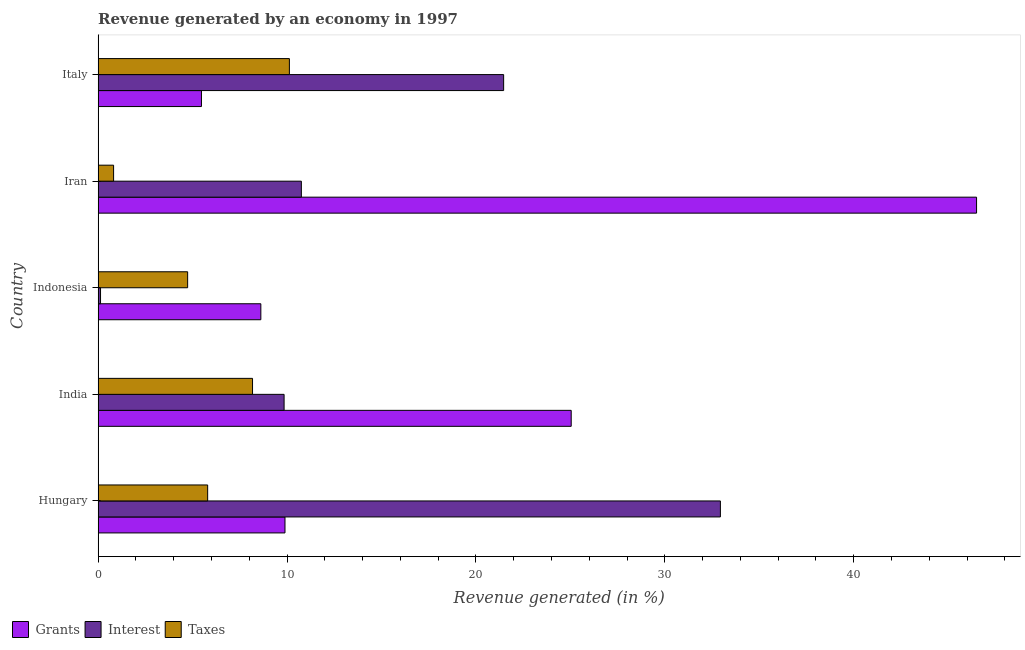How many groups of bars are there?
Your answer should be compact. 5. Are the number of bars per tick equal to the number of legend labels?
Make the answer very short. Yes. What is the percentage of revenue generated by interest in Hungary?
Offer a terse response. 32.94. Across all countries, what is the maximum percentage of revenue generated by interest?
Provide a succinct answer. 32.94. Across all countries, what is the minimum percentage of revenue generated by taxes?
Give a very brief answer. 0.82. In which country was the percentage of revenue generated by taxes minimum?
Make the answer very short. Iran. What is the total percentage of revenue generated by interest in the graph?
Your answer should be very brief. 75.14. What is the difference between the percentage of revenue generated by taxes in India and that in Iran?
Make the answer very short. 7.36. What is the difference between the percentage of revenue generated by interest in Iran and the percentage of revenue generated by grants in India?
Make the answer very short. -14.29. What is the average percentage of revenue generated by grants per country?
Your answer should be compact. 19.11. What is the difference between the percentage of revenue generated by taxes and percentage of revenue generated by interest in Indonesia?
Your answer should be very brief. 4.61. In how many countries, is the percentage of revenue generated by grants greater than 20 %?
Your answer should be compact. 2. What is the ratio of the percentage of revenue generated by interest in Indonesia to that in Iran?
Provide a short and direct response. 0.01. Is the percentage of revenue generated by grants in India less than that in Iran?
Provide a short and direct response. Yes. Is the difference between the percentage of revenue generated by grants in India and Iran greater than the difference between the percentage of revenue generated by interest in India and Iran?
Provide a short and direct response. No. What is the difference between the highest and the second highest percentage of revenue generated by taxes?
Ensure brevity in your answer.  1.95. What is the difference between the highest and the lowest percentage of revenue generated by taxes?
Provide a succinct answer. 9.31. In how many countries, is the percentage of revenue generated by interest greater than the average percentage of revenue generated by interest taken over all countries?
Your answer should be very brief. 2. Is the sum of the percentage of revenue generated by taxes in Hungary and Indonesia greater than the maximum percentage of revenue generated by grants across all countries?
Keep it short and to the point. No. What does the 2nd bar from the top in Italy represents?
Your answer should be very brief. Interest. What does the 1st bar from the bottom in India represents?
Provide a short and direct response. Grants. Is it the case that in every country, the sum of the percentage of revenue generated by grants and percentage of revenue generated by interest is greater than the percentage of revenue generated by taxes?
Provide a short and direct response. Yes. How many bars are there?
Give a very brief answer. 15. Are all the bars in the graph horizontal?
Your response must be concise. Yes. How many countries are there in the graph?
Give a very brief answer. 5. What is the difference between two consecutive major ticks on the X-axis?
Your answer should be very brief. 10. Does the graph contain any zero values?
Provide a short and direct response. No. How are the legend labels stacked?
Keep it short and to the point. Horizontal. What is the title of the graph?
Provide a short and direct response. Revenue generated by an economy in 1997. What is the label or title of the X-axis?
Provide a succinct answer. Revenue generated (in %). What is the label or title of the Y-axis?
Your answer should be compact. Country. What is the Revenue generated (in %) in Grants in Hungary?
Keep it short and to the point. 9.89. What is the Revenue generated (in %) of Interest in Hungary?
Offer a terse response. 32.94. What is the Revenue generated (in %) of Taxes in Hungary?
Make the answer very short. 5.8. What is the Revenue generated (in %) of Grants in India?
Provide a succinct answer. 25.04. What is the Revenue generated (in %) of Interest in India?
Your response must be concise. 9.85. What is the Revenue generated (in %) in Taxes in India?
Provide a succinct answer. 8.17. What is the Revenue generated (in %) of Grants in Indonesia?
Ensure brevity in your answer.  8.61. What is the Revenue generated (in %) of Interest in Indonesia?
Provide a short and direct response. 0.13. What is the Revenue generated (in %) of Taxes in Indonesia?
Your response must be concise. 4.74. What is the Revenue generated (in %) of Grants in Iran?
Provide a short and direct response. 46.5. What is the Revenue generated (in %) of Interest in Iran?
Give a very brief answer. 10.76. What is the Revenue generated (in %) of Taxes in Iran?
Keep it short and to the point. 0.82. What is the Revenue generated (in %) in Grants in Italy?
Your answer should be very brief. 5.47. What is the Revenue generated (in %) in Interest in Italy?
Give a very brief answer. 21.47. What is the Revenue generated (in %) of Taxes in Italy?
Provide a succinct answer. 10.13. Across all countries, what is the maximum Revenue generated (in %) in Grants?
Your answer should be very brief. 46.5. Across all countries, what is the maximum Revenue generated (in %) of Interest?
Offer a very short reply. 32.94. Across all countries, what is the maximum Revenue generated (in %) of Taxes?
Your answer should be very brief. 10.13. Across all countries, what is the minimum Revenue generated (in %) in Grants?
Your answer should be compact. 5.47. Across all countries, what is the minimum Revenue generated (in %) of Interest?
Give a very brief answer. 0.13. Across all countries, what is the minimum Revenue generated (in %) of Taxes?
Offer a terse response. 0.82. What is the total Revenue generated (in %) in Grants in the graph?
Offer a very short reply. 95.52. What is the total Revenue generated (in %) in Interest in the graph?
Offer a terse response. 75.14. What is the total Revenue generated (in %) of Taxes in the graph?
Provide a succinct answer. 29.66. What is the difference between the Revenue generated (in %) of Grants in Hungary and that in India?
Your answer should be compact. -15.15. What is the difference between the Revenue generated (in %) in Interest in Hungary and that in India?
Keep it short and to the point. 23.1. What is the difference between the Revenue generated (in %) in Taxes in Hungary and that in India?
Your answer should be very brief. -2.37. What is the difference between the Revenue generated (in %) in Grants in Hungary and that in Indonesia?
Provide a succinct answer. 1.28. What is the difference between the Revenue generated (in %) of Interest in Hungary and that in Indonesia?
Provide a succinct answer. 32.81. What is the difference between the Revenue generated (in %) in Taxes in Hungary and that in Indonesia?
Your response must be concise. 1.06. What is the difference between the Revenue generated (in %) of Grants in Hungary and that in Iran?
Provide a succinct answer. -36.61. What is the difference between the Revenue generated (in %) in Interest in Hungary and that in Iran?
Provide a short and direct response. 22.18. What is the difference between the Revenue generated (in %) in Taxes in Hungary and that in Iran?
Your answer should be compact. 4.98. What is the difference between the Revenue generated (in %) in Grants in Hungary and that in Italy?
Your answer should be compact. 4.42. What is the difference between the Revenue generated (in %) of Interest in Hungary and that in Italy?
Make the answer very short. 11.47. What is the difference between the Revenue generated (in %) of Taxes in Hungary and that in Italy?
Your response must be concise. -4.33. What is the difference between the Revenue generated (in %) in Grants in India and that in Indonesia?
Offer a terse response. 16.43. What is the difference between the Revenue generated (in %) in Interest in India and that in Indonesia?
Provide a succinct answer. 9.72. What is the difference between the Revenue generated (in %) in Taxes in India and that in Indonesia?
Give a very brief answer. 3.44. What is the difference between the Revenue generated (in %) in Grants in India and that in Iran?
Your response must be concise. -21.46. What is the difference between the Revenue generated (in %) in Interest in India and that in Iran?
Offer a very short reply. -0.91. What is the difference between the Revenue generated (in %) of Taxes in India and that in Iran?
Make the answer very short. 7.36. What is the difference between the Revenue generated (in %) in Grants in India and that in Italy?
Make the answer very short. 19.57. What is the difference between the Revenue generated (in %) in Interest in India and that in Italy?
Make the answer very short. -11.62. What is the difference between the Revenue generated (in %) of Taxes in India and that in Italy?
Your answer should be compact. -1.95. What is the difference between the Revenue generated (in %) in Grants in Indonesia and that in Iran?
Ensure brevity in your answer.  -37.89. What is the difference between the Revenue generated (in %) of Interest in Indonesia and that in Iran?
Keep it short and to the point. -10.63. What is the difference between the Revenue generated (in %) of Taxes in Indonesia and that in Iran?
Your response must be concise. 3.92. What is the difference between the Revenue generated (in %) of Grants in Indonesia and that in Italy?
Your answer should be compact. 3.14. What is the difference between the Revenue generated (in %) in Interest in Indonesia and that in Italy?
Your answer should be very brief. -21.34. What is the difference between the Revenue generated (in %) of Taxes in Indonesia and that in Italy?
Your answer should be very brief. -5.39. What is the difference between the Revenue generated (in %) of Grants in Iran and that in Italy?
Ensure brevity in your answer.  41.03. What is the difference between the Revenue generated (in %) in Interest in Iran and that in Italy?
Provide a short and direct response. -10.71. What is the difference between the Revenue generated (in %) in Taxes in Iran and that in Italy?
Give a very brief answer. -9.31. What is the difference between the Revenue generated (in %) in Grants in Hungary and the Revenue generated (in %) in Interest in India?
Provide a short and direct response. 0.05. What is the difference between the Revenue generated (in %) in Grants in Hungary and the Revenue generated (in %) in Taxes in India?
Give a very brief answer. 1.72. What is the difference between the Revenue generated (in %) in Interest in Hungary and the Revenue generated (in %) in Taxes in India?
Provide a succinct answer. 24.77. What is the difference between the Revenue generated (in %) in Grants in Hungary and the Revenue generated (in %) in Interest in Indonesia?
Give a very brief answer. 9.76. What is the difference between the Revenue generated (in %) of Grants in Hungary and the Revenue generated (in %) of Taxes in Indonesia?
Ensure brevity in your answer.  5.15. What is the difference between the Revenue generated (in %) of Interest in Hungary and the Revenue generated (in %) of Taxes in Indonesia?
Give a very brief answer. 28.2. What is the difference between the Revenue generated (in %) of Grants in Hungary and the Revenue generated (in %) of Interest in Iran?
Make the answer very short. -0.87. What is the difference between the Revenue generated (in %) of Grants in Hungary and the Revenue generated (in %) of Taxes in Iran?
Offer a very short reply. 9.07. What is the difference between the Revenue generated (in %) in Interest in Hungary and the Revenue generated (in %) in Taxes in Iran?
Give a very brief answer. 32.12. What is the difference between the Revenue generated (in %) in Grants in Hungary and the Revenue generated (in %) in Interest in Italy?
Provide a succinct answer. -11.58. What is the difference between the Revenue generated (in %) of Grants in Hungary and the Revenue generated (in %) of Taxes in Italy?
Your response must be concise. -0.23. What is the difference between the Revenue generated (in %) in Interest in Hungary and the Revenue generated (in %) in Taxes in Italy?
Ensure brevity in your answer.  22.82. What is the difference between the Revenue generated (in %) of Grants in India and the Revenue generated (in %) of Interest in Indonesia?
Offer a terse response. 24.92. What is the difference between the Revenue generated (in %) of Grants in India and the Revenue generated (in %) of Taxes in Indonesia?
Provide a short and direct response. 20.31. What is the difference between the Revenue generated (in %) in Interest in India and the Revenue generated (in %) in Taxes in Indonesia?
Offer a very short reply. 5.11. What is the difference between the Revenue generated (in %) in Grants in India and the Revenue generated (in %) in Interest in Iran?
Ensure brevity in your answer.  14.29. What is the difference between the Revenue generated (in %) of Grants in India and the Revenue generated (in %) of Taxes in Iran?
Your answer should be very brief. 24.23. What is the difference between the Revenue generated (in %) in Interest in India and the Revenue generated (in %) in Taxes in Iran?
Keep it short and to the point. 9.03. What is the difference between the Revenue generated (in %) in Grants in India and the Revenue generated (in %) in Interest in Italy?
Ensure brevity in your answer.  3.58. What is the difference between the Revenue generated (in %) in Grants in India and the Revenue generated (in %) in Taxes in Italy?
Your response must be concise. 14.92. What is the difference between the Revenue generated (in %) of Interest in India and the Revenue generated (in %) of Taxes in Italy?
Make the answer very short. -0.28. What is the difference between the Revenue generated (in %) of Grants in Indonesia and the Revenue generated (in %) of Interest in Iran?
Keep it short and to the point. -2.15. What is the difference between the Revenue generated (in %) in Grants in Indonesia and the Revenue generated (in %) in Taxes in Iran?
Ensure brevity in your answer.  7.8. What is the difference between the Revenue generated (in %) in Interest in Indonesia and the Revenue generated (in %) in Taxes in Iran?
Make the answer very short. -0.69. What is the difference between the Revenue generated (in %) of Grants in Indonesia and the Revenue generated (in %) of Interest in Italy?
Your response must be concise. -12.85. What is the difference between the Revenue generated (in %) of Grants in Indonesia and the Revenue generated (in %) of Taxes in Italy?
Give a very brief answer. -1.51. What is the difference between the Revenue generated (in %) in Interest in Indonesia and the Revenue generated (in %) in Taxes in Italy?
Offer a terse response. -10. What is the difference between the Revenue generated (in %) in Grants in Iran and the Revenue generated (in %) in Interest in Italy?
Keep it short and to the point. 25.04. What is the difference between the Revenue generated (in %) of Grants in Iran and the Revenue generated (in %) of Taxes in Italy?
Ensure brevity in your answer.  36.38. What is the difference between the Revenue generated (in %) of Interest in Iran and the Revenue generated (in %) of Taxes in Italy?
Make the answer very short. 0.63. What is the average Revenue generated (in %) in Grants per country?
Your answer should be compact. 19.1. What is the average Revenue generated (in %) of Interest per country?
Ensure brevity in your answer.  15.03. What is the average Revenue generated (in %) of Taxes per country?
Keep it short and to the point. 5.93. What is the difference between the Revenue generated (in %) of Grants and Revenue generated (in %) of Interest in Hungary?
Your answer should be very brief. -23.05. What is the difference between the Revenue generated (in %) of Grants and Revenue generated (in %) of Taxes in Hungary?
Keep it short and to the point. 4.09. What is the difference between the Revenue generated (in %) in Interest and Revenue generated (in %) in Taxes in Hungary?
Your response must be concise. 27.14. What is the difference between the Revenue generated (in %) in Grants and Revenue generated (in %) in Interest in India?
Provide a succinct answer. 15.2. What is the difference between the Revenue generated (in %) of Grants and Revenue generated (in %) of Taxes in India?
Your answer should be compact. 16.87. What is the difference between the Revenue generated (in %) of Interest and Revenue generated (in %) of Taxes in India?
Make the answer very short. 1.67. What is the difference between the Revenue generated (in %) in Grants and Revenue generated (in %) in Interest in Indonesia?
Make the answer very short. 8.49. What is the difference between the Revenue generated (in %) of Grants and Revenue generated (in %) of Taxes in Indonesia?
Make the answer very short. 3.88. What is the difference between the Revenue generated (in %) of Interest and Revenue generated (in %) of Taxes in Indonesia?
Provide a short and direct response. -4.61. What is the difference between the Revenue generated (in %) of Grants and Revenue generated (in %) of Interest in Iran?
Offer a terse response. 35.74. What is the difference between the Revenue generated (in %) of Grants and Revenue generated (in %) of Taxes in Iran?
Provide a succinct answer. 45.68. What is the difference between the Revenue generated (in %) of Interest and Revenue generated (in %) of Taxes in Iran?
Provide a succinct answer. 9.94. What is the difference between the Revenue generated (in %) in Grants and Revenue generated (in %) in Interest in Italy?
Your answer should be very brief. -16. What is the difference between the Revenue generated (in %) of Grants and Revenue generated (in %) of Taxes in Italy?
Your answer should be compact. -4.66. What is the difference between the Revenue generated (in %) in Interest and Revenue generated (in %) in Taxes in Italy?
Make the answer very short. 11.34. What is the ratio of the Revenue generated (in %) of Grants in Hungary to that in India?
Provide a short and direct response. 0.4. What is the ratio of the Revenue generated (in %) of Interest in Hungary to that in India?
Your response must be concise. 3.35. What is the ratio of the Revenue generated (in %) in Taxes in Hungary to that in India?
Your answer should be very brief. 0.71. What is the ratio of the Revenue generated (in %) in Grants in Hungary to that in Indonesia?
Offer a terse response. 1.15. What is the ratio of the Revenue generated (in %) of Interest in Hungary to that in Indonesia?
Give a very brief answer. 257.78. What is the ratio of the Revenue generated (in %) of Taxes in Hungary to that in Indonesia?
Offer a terse response. 1.22. What is the ratio of the Revenue generated (in %) of Grants in Hungary to that in Iran?
Offer a very short reply. 0.21. What is the ratio of the Revenue generated (in %) of Interest in Hungary to that in Iran?
Offer a very short reply. 3.06. What is the ratio of the Revenue generated (in %) of Taxes in Hungary to that in Iran?
Your response must be concise. 7.08. What is the ratio of the Revenue generated (in %) of Grants in Hungary to that in Italy?
Your response must be concise. 1.81. What is the ratio of the Revenue generated (in %) in Interest in Hungary to that in Italy?
Your answer should be very brief. 1.53. What is the ratio of the Revenue generated (in %) in Taxes in Hungary to that in Italy?
Your answer should be compact. 0.57. What is the ratio of the Revenue generated (in %) of Grants in India to that in Indonesia?
Offer a very short reply. 2.91. What is the ratio of the Revenue generated (in %) in Interest in India to that in Indonesia?
Provide a succinct answer. 77.04. What is the ratio of the Revenue generated (in %) of Taxes in India to that in Indonesia?
Give a very brief answer. 1.72. What is the ratio of the Revenue generated (in %) in Grants in India to that in Iran?
Provide a succinct answer. 0.54. What is the ratio of the Revenue generated (in %) in Interest in India to that in Iran?
Your answer should be very brief. 0.92. What is the ratio of the Revenue generated (in %) in Taxes in India to that in Iran?
Make the answer very short. 9.98. What is the ratio of the Revenue generated (in %) of Grants in India to that in Italy?
Provide a short and direct response. 4.58. What is the ratio of the Revenue generated (in %) in Interest in India to that in Italy?
Ensure brevity in your answer.  0.46. What is the ratio of the Revenue generated (in %) in Taxes in India to that in Italy?
Ensure brevity in your answer.  0.81. What is the ratio of the Revenue generated (in %) in Grants in Indonesia to that in Iran?
Give a very brief answer. 0.19. What is the ratio of the Revenue generated (in %) of Interest in Indonesia to that in Iran?
Keep it short and to the point. 0.01. What is the ratio of the Revenue generated (in %) of Taxes in Indonesia to that in Iran?
Keep it short and to the point. 5.79. What is the ratio of the Revenue generated (in %) in Grants in Indonesia to that in Italy?
Your answer should be very brief. 1.57. What is the ratio of the Revenue generated (in %) in Interest in Indonesia to that in Italy?
Your answer should be very brief. 0.01. What is the ratio of the Revenue generated (in %) of Taxes in Indonesia to that in Italy?
Your answer should be very brief. 0.47. What is the ratio of the Revenue generated (in %) in Grants in Iran to that in Italy?
Give a very brief answer. 8.5. What is the ratio of the Revenue generated (in %) of Interest in Iran to that in Italy?
Provide a short and direct response. 0.5. What is the ratio of the Revenue generated (in %) in Taxes in Iran to that in Italy?
Your answer should be compact. 0.08. What is the difference between the highest and the second highest Revenue generated (in %) of Grants?
Make the answer very short. 21.46. What is the difference between the highest and the second highest Revenue generated (in %) of Interest?
Offer a terse response. 11.47. What is the difference between the highest and the second highest Revenue generated (in %) in Taxes?
Ensure brevity in your answer.  1.95. What is the difference between the highest and the lowest Revenue generated (in %) in Grants?
Provide a short and direct response. 41.03. What is the difference between the highest and the lowest Revenue generated (in %) in Interest?
Your response must be concise. 32.81. What is the difference between the highest and the lowest Revenue generated (in %) in Taxes?
Give a very brief answer. 9.31. 